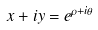Convert formula to latex. <formula><loc_0><loc_0><loc_500><loc_500>x + i y = e ^ { \rho + i \theta }</formula> 